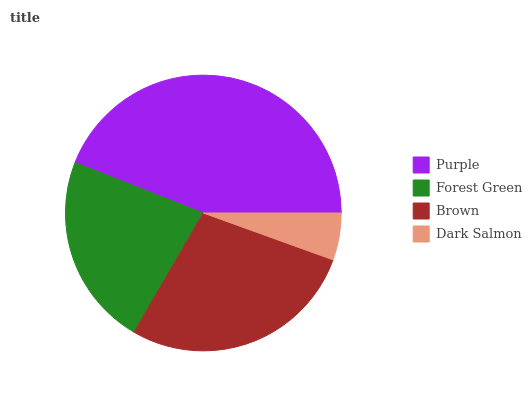Is Dark Salmon the minimum?
Answer yes or no. Yes. Is Purple the maximum?
Answer yes or no. Yes. Is Forest Green the minimum?
Answer yes or no. No. Is Forest Green the maximum?
Answer yes or no. No. Is Purple greater than Forest Green?
Answer yes or no. Yes. Is Forest Green less than Purple?
Answer yes or no. Yes. Is Forest Green greater than Purple?
Answer yes or no. No. Is Purple less than Forest Green?
Answer yes or no. No. Is Brown the high median?
Answer yes or no. Yes. Is Forest Green the low median?
Answer yes or no. Yes. Is Forest Green the high median?
Answer yes or no. No. Is Brown the low median?
Answer yes or no. No. 